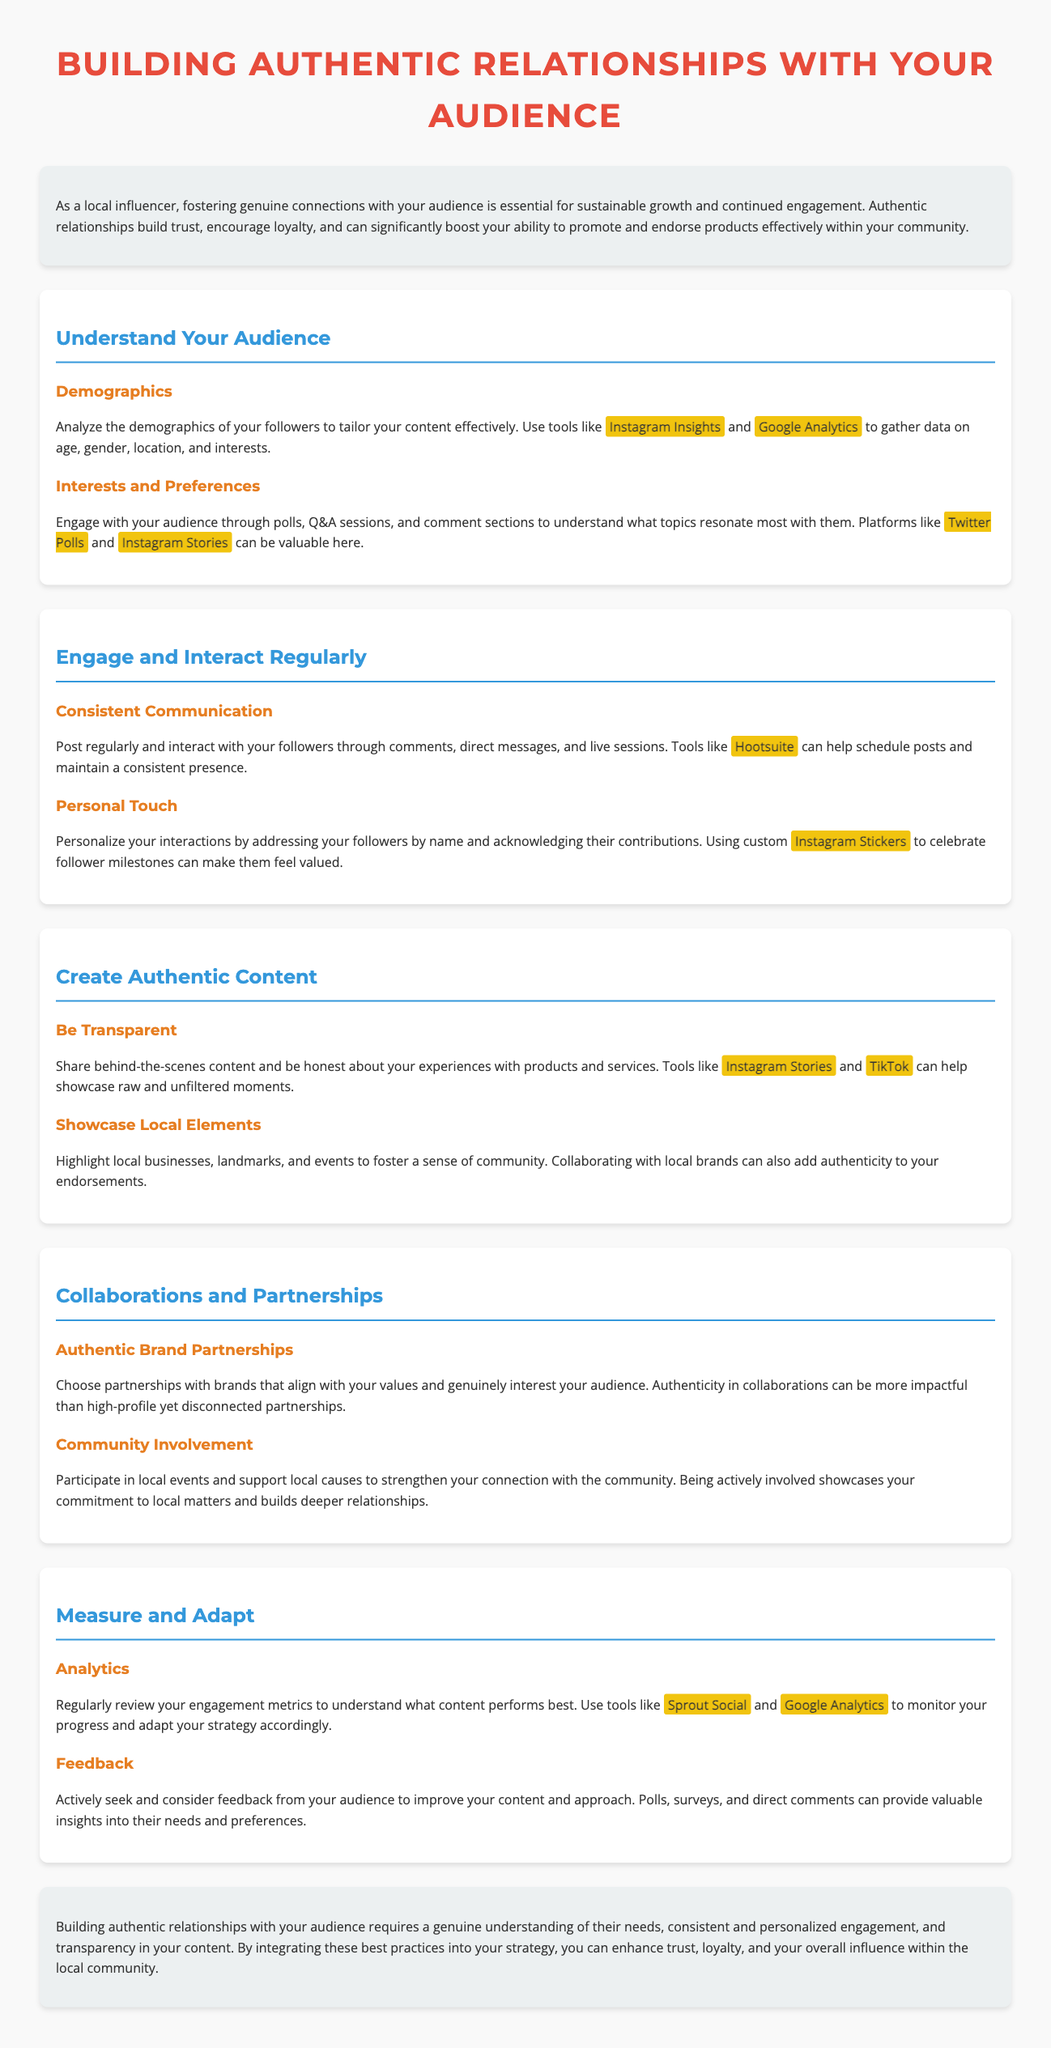what is the title of the whitepaper? The title of the whitepaper is prominently displayed at the top of the document.
Answer: Building Authentic Relationships with Your Audience what section discusses engaging with your audience? This section details methods of communication and interaction with followers.
Answer: Engage and Interact Regularly how can you analyze your audience's demographics? The document mentions tools that help gather data on various demographic factors.
Answer: Instagram Insights and Google Analytics what tool can help maintain a consistent posting schedule? This tool is recommended to schedule posts and maintain an influencer's presence.
Answer: Hootsuite what is highlighted as a method to understand audience interests? The document describes activities that can help gather insights on what resonates with followers.
Answer: Polls, Q&A sessions, and comment sections which practice enhances trust and connection within a community? The document emphasizes a specific action that showcases commitment to the local community.
Answer: Community Involvement why is it important to be transparent with content? The document explains the value of authenticity in fostering relationships with the audience.
Answer: Builds trust what is suggested to monitor content performance? Regular review of engagement metrics is recommended for monitoring effectiveness.
Answer: Analytics which social media platform is recommended for showcasing behind-the-scenes content? The document suggests a specific platform for sharing raw moments with the audience.
Answer: Instagram Stories 